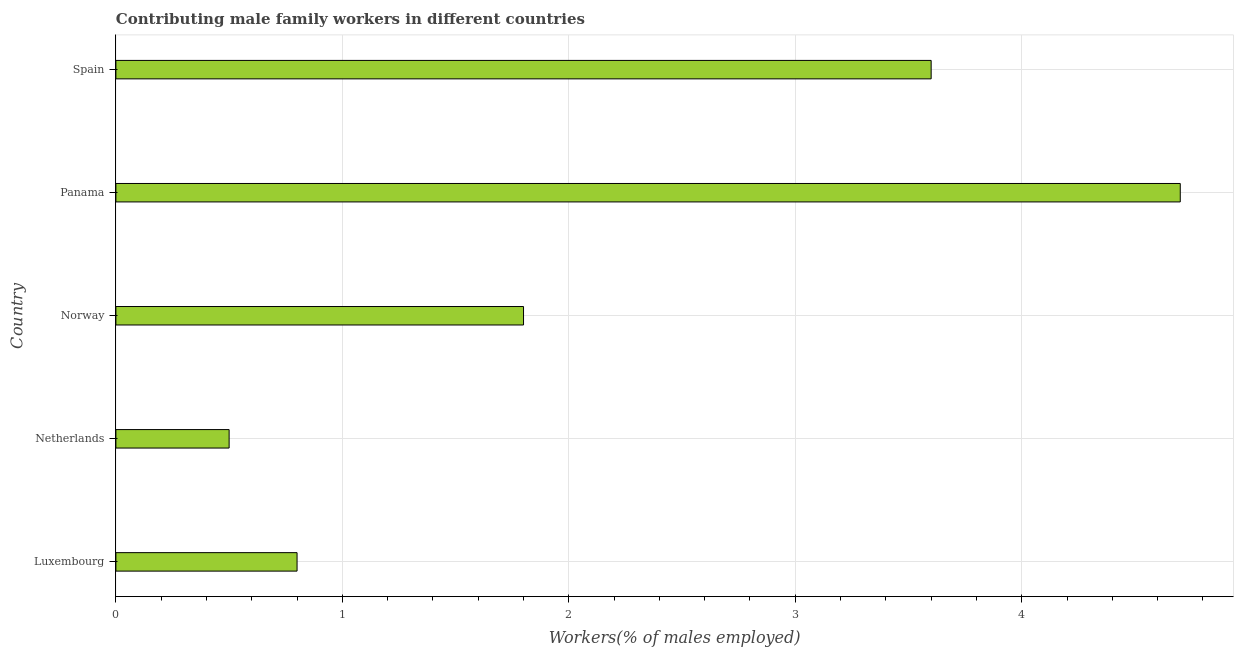What is the title of the graph?
Make the answer very short. Contributing male family workers in different countries. What is the label or title of the X-axis?
Your response must be concise. Workers(% of males employed). What is the label or title of the Y-axis?
Your response must be concise. Country. What is the contributing male family workers in Spain?
Your answer should be compact. 3.6. Across all countries, what is the maximum contributing male family workers?
Offer a very short reply. 4.7. Across all countries, what is the minimum contributing male family workers?
Offer a very short reply. 0.5. In which country was the contributing male family workers maximum?
Your answer should be compact. Panama. What is the sum of the contributing male family workers?
Make the answer very short. 11.4. What is the average contributing male family workers per country?
Your answer should be compact. 2.28. What is the median contributing male family workers?
Your response must be concise. 1.8. What is the ratio of the contributing male family workers in Netherlands to that in Panama?
Provide a short and direct response. 0.11. What is the Workers(% of males employed) of Luxembourg?
Provide a short and direct response. 0.8. What is the Workers(% of males employed) in Netherlands?
Provide a short and direct response. 0.5. What is the Workers(% of males employed) in Norway?
Your response must be concise. 1.8. What is the Workers(% of males employed) in Panama?
Offer a very short reply. 4.7. What is the Workers(% of males employed) in Spain?
Your answer should be very brief. 3.6. What is the difference between the Workers(% of males employed) in Luxembourg and Spain?
Your answer should be compact. -2.8. What is the difference between the Workers(% of males employed) in Netherlands and Norway?
Keep it short and to the point. -1.3. What is the difference between the Workers(% of males employed) in Norway and Spain?
Provide a succinct answer. -1.8. What is the difference between the Workers(% of males employed) in Panama and Spain?
Provide a succinct answer. 1.1. What is the ratio of the Workers(% of males employed) in Luxembourg to that in Norway?
Offer a very short reply. 0.44. What is the ratio of the Workers(% of males employed) in Luxembourg to that in Panama?
Ensure brevity in your answer.  0.17. What is the ratio of the Workers(% of males employed) in Luxembourg to that in Spain?
Give a very brief answer. 0.22. What is the ratio of the Workers(% of males employed) in Netherlands to that in Norway?
Make the answer very short. 0.28. What is the ratio of the Workers(% of males employed) in Netherlands to that in Panama?
Your response must be concise. 0.11. What is the ratio of the Workers(% of males employed) in Netherlands to that in Spain?
Your answer should be compact. 0.14. What is the ratio of the Workers(% of males employed) in Norway to that in Panama?
Ensure brevity in your answer.  0.38. What is the ratio of the Workers(% of males employed) in Norway to that in Spain?
Your response must be concise. 0.5. What is the ratio of the Workers(% of males employed) in Panama to that in Spain?
Ensure brevity in your answer.  1.31. 